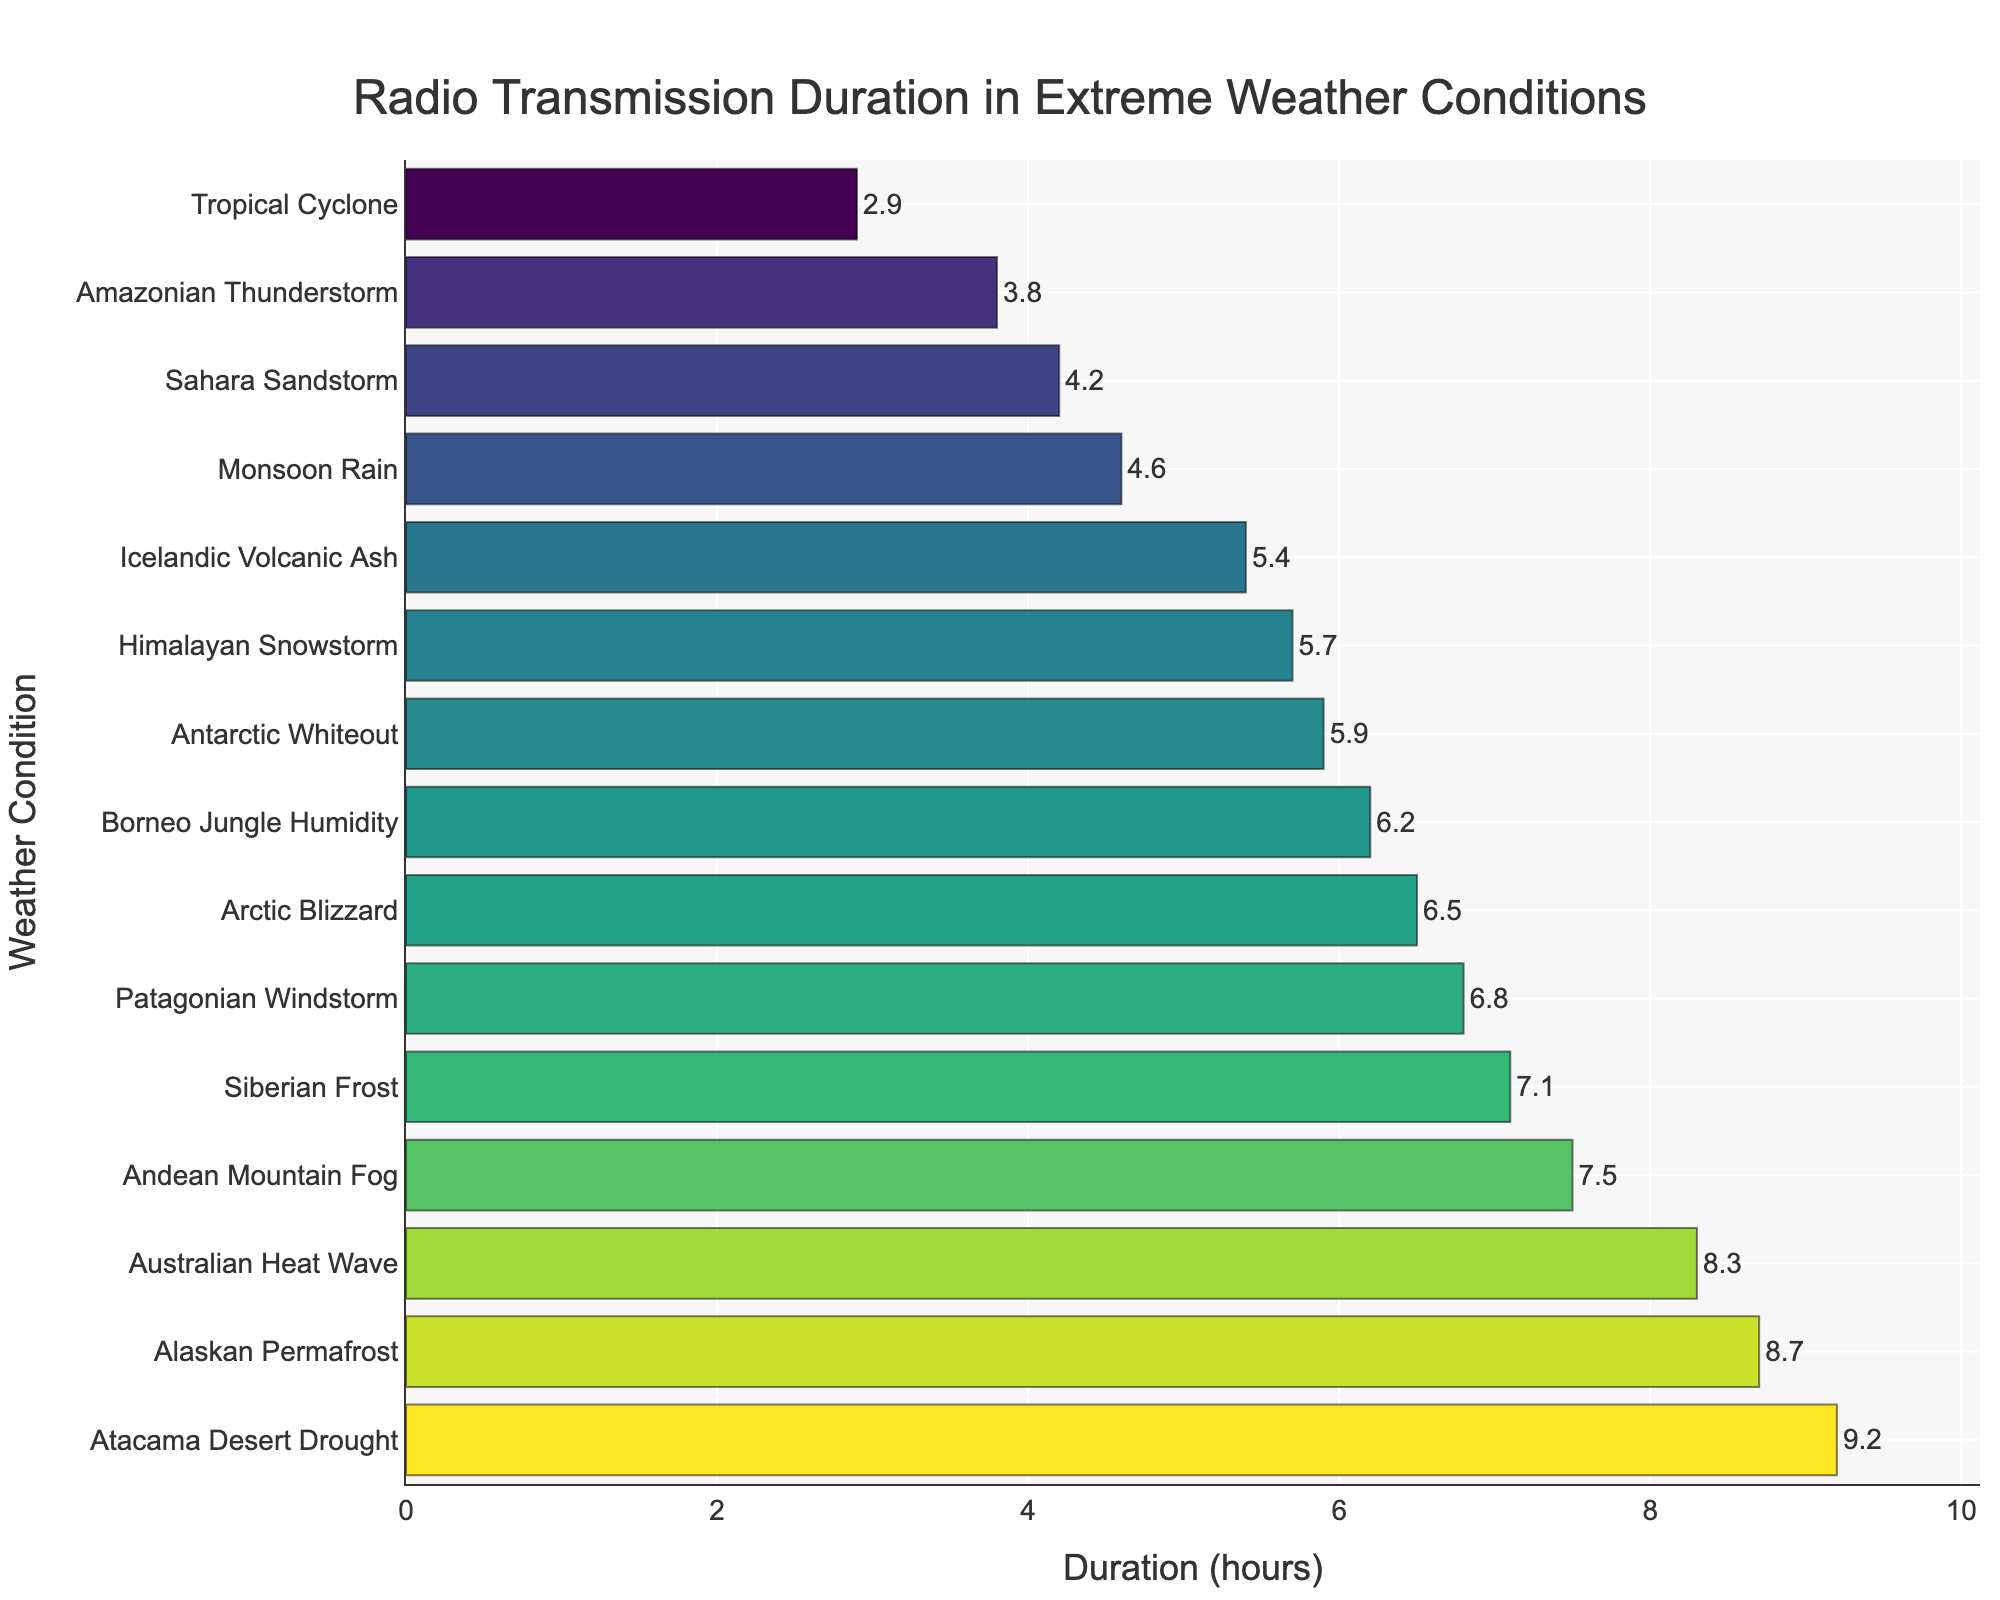What's the longest duration of radio transmission in any weather condition? Refer to the bar that extends the furthest to the right. The longest bar corresponds to the Atacama Desert Drought with 9.2 hours.
Answer: 9.2 hours Which weather condition had the shortest radio transmission duration? Identify the shortest bar on the graph. The bar for Tropical Cyclone is the shortest, indicating a duration of 2.9 hours.
Answer: Tropical Cyclone What is the total duration of radio transmissions in Arctic Blizzard and Antarctic Whiteout combined? Add the durations for Arctic Blizzard (6.5 hours) and Antarctic Whiteout (5.9 hours). 6.5 + 5.9 = 12.4 hours.
Answer: 12.4 hours How much longer is the radio transmission in the Australian Heat Wave compared to the Amazonian Thunderstorm? Subtract the duration of Amazonian Thunderstorm (3.8 hours) from Australian Heat Wave (8.3 hours). 8.3 - 3.8 = 4.5 hours.
Answer: 4.5 hours Which weather condition had approximately twice the transmission duration compared to Monsoon Rain? Find the duration for Monsoon Rain (4.6 hours) and look for a duration close to 4.6 × 2 = 9.2 hours. The closest is Atacama Desert Drought with 9.2 hours.
Answer: Atacama Desert Drought Compare the radio transmission duration in Alaskan Permafrost and Borneo Jungle Humidity. Which one is higher, and by how much? The duration in Alaskan Permafrost is 8.7 hours and in Borneo Jungle Humidity is 6.2 hours. Subtract the shorter duration from the longer one: 8.7 - 6.2 = 2.5 hours.
Answer: Alaskan Permafrost, 2.5 hours What is the average duration of radio transmissions across all weather conditions? Sum all durations and divide by the number of weather conditions. (6.5 + 4.2 + 3.8 + 5.7 + 8.3 + 7.1 + 2.9 + 5.4 + 6.8 + 4.6 + 9.2 + 5.9 + 7.5 + 8.7 + 6.2) / 15 = 5.93 hours.
Answer: 5.93 hours Which weather condition achieved a similar duration as the Icelandic Volcanic Ash? The duration for Icelandic Volcanic Ash is 5.4 hours. The closest similar duration is Himalayan Snowstorm at 5.7 hours.
Answer: Himalayan Snowstorm What is the difference in duration between the longest and shortest radio transmission conditions? Subtract the duration of the shortest condition (Tropical Cyclone, 2.9 hours) from the longest (Atacama Desert Drought, 9.2 hours). 9.2 - 2.9 = 6.3 hours.
Answer: 6.3 hours 